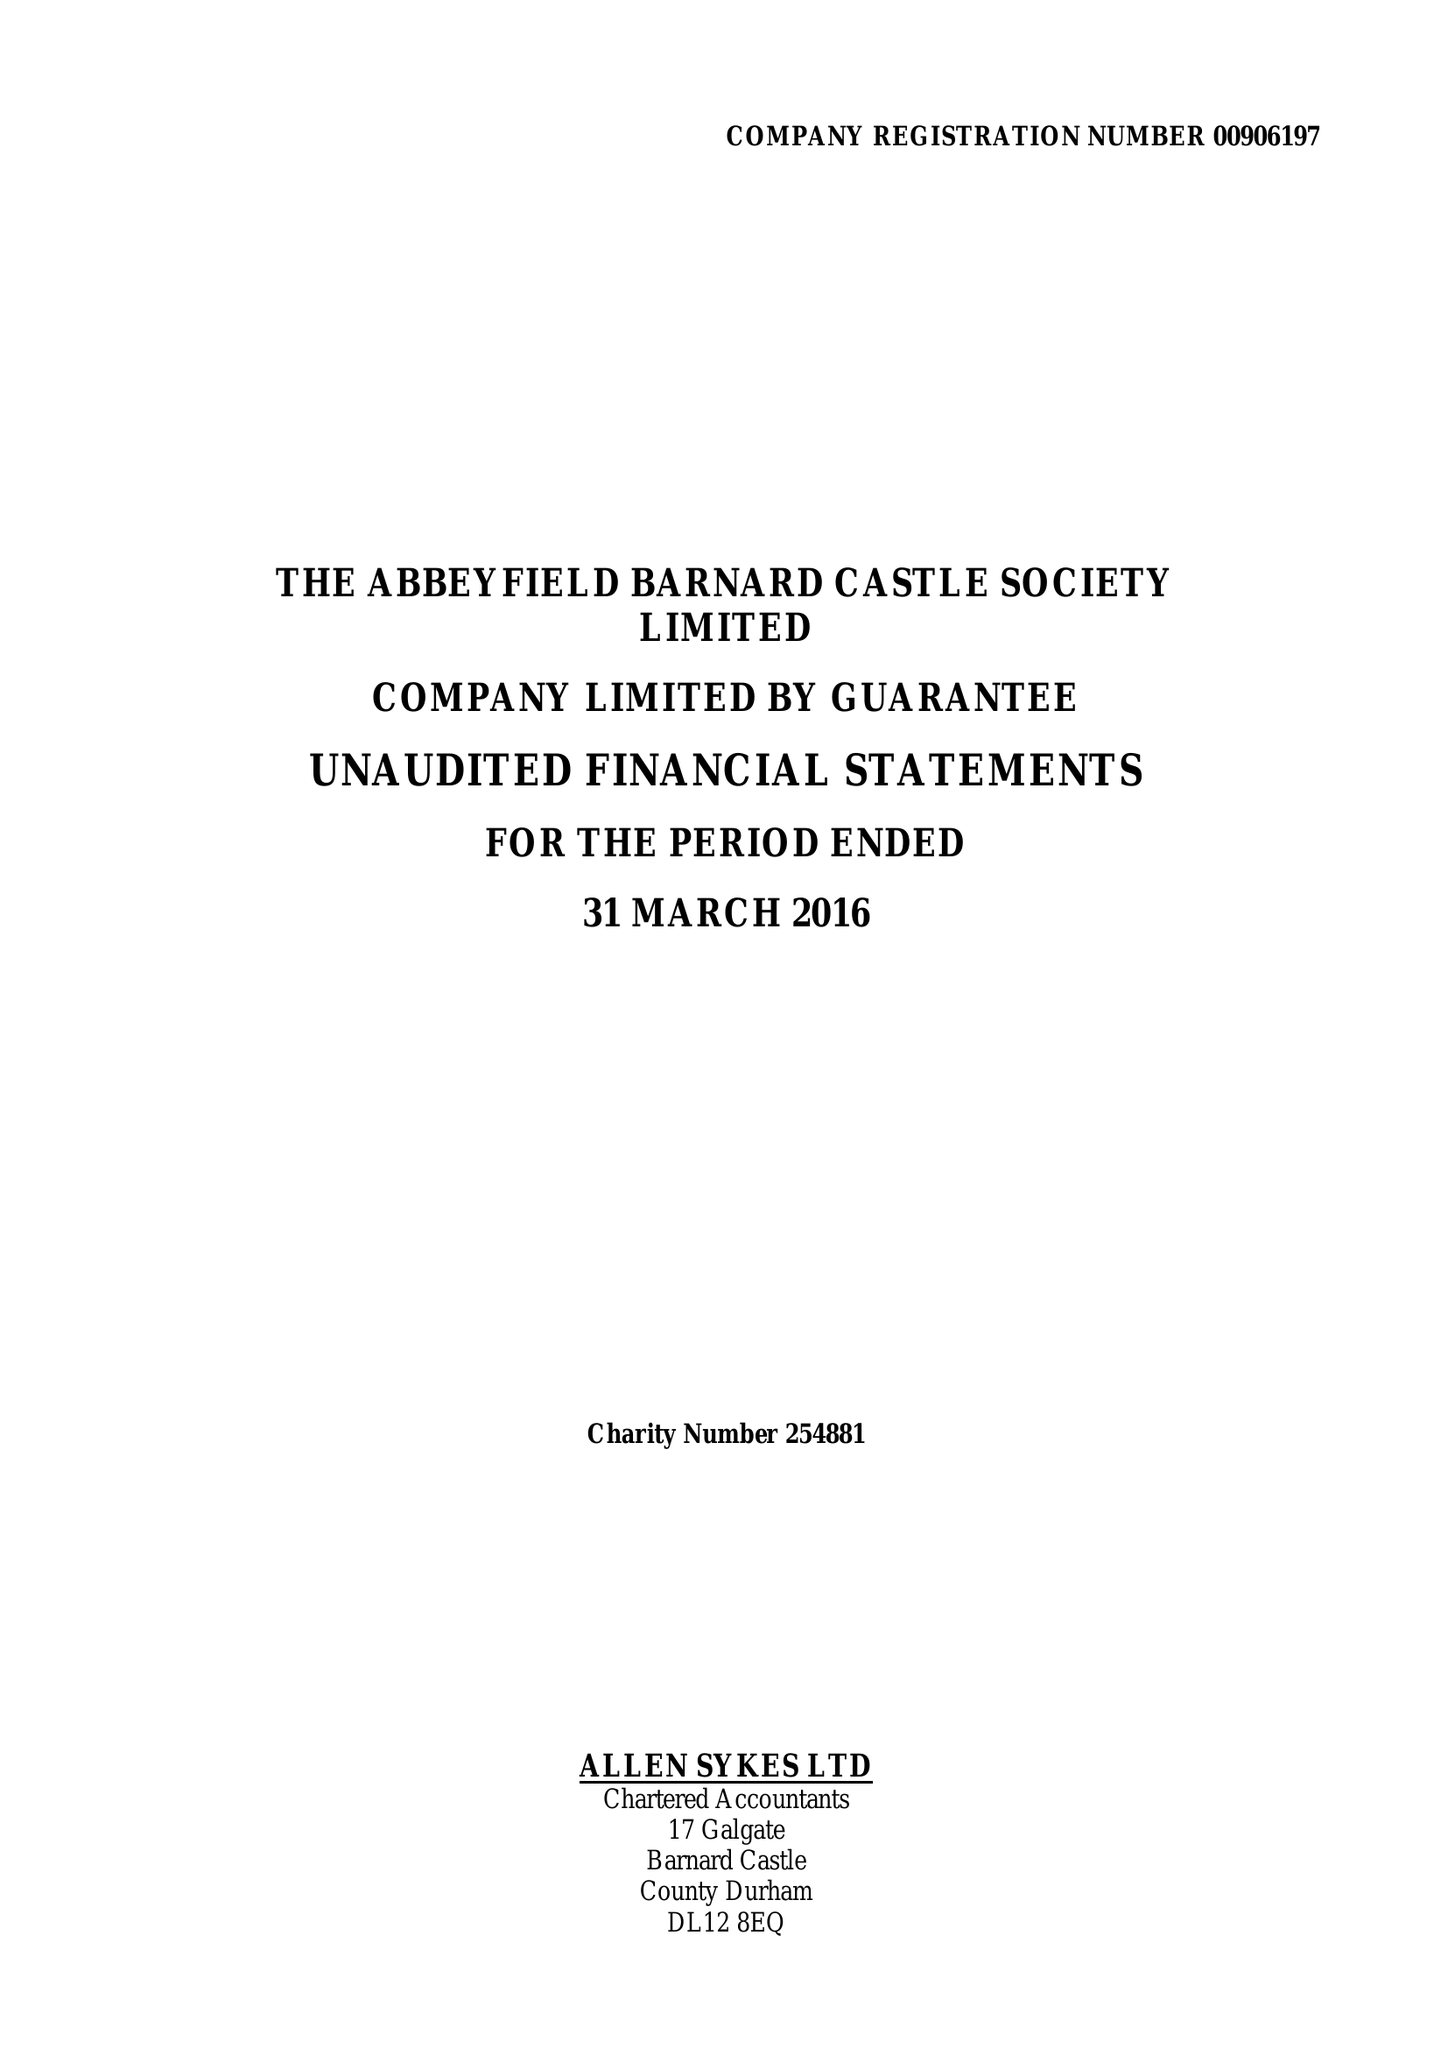What is the value for the address__postcode?
Answer the question using a single word or phrase. DL12 8BL 